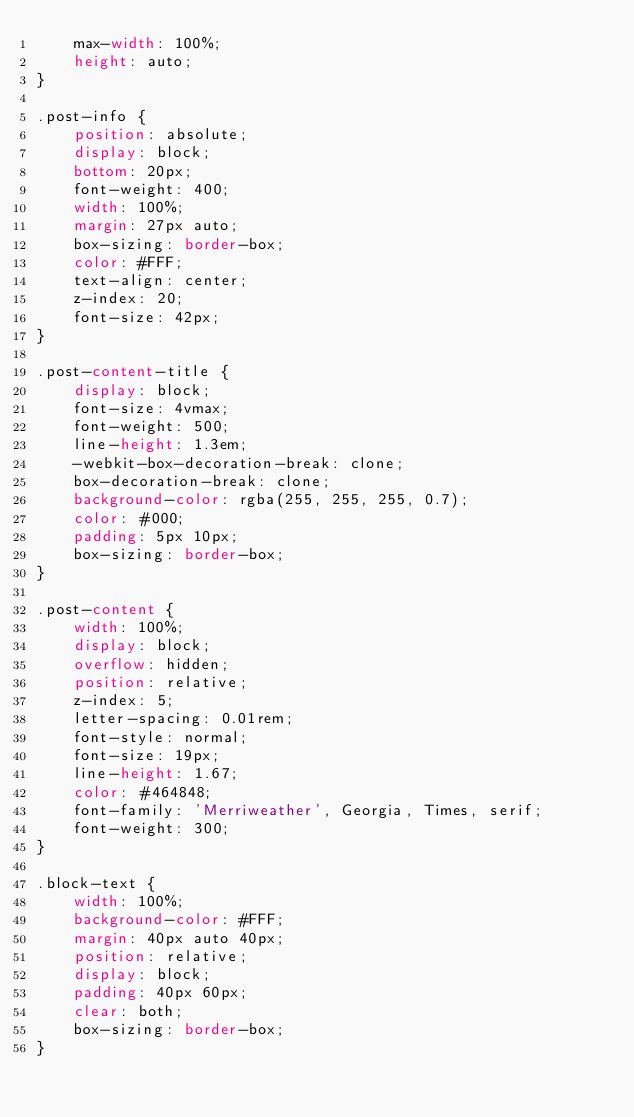<code> <loc_0><loc_0><loc_500><loc_500><_CSS_>    max-width: 100%;
    height: auto;
}

.post-info {
    position: absolute;
    display: block;
    bottom: 20px;
    font-weight: 400;
    width: 100%;
    margin: 27px auto;
    box-sizing: border-box;
    color: #FFF;
    text-align: center;
    z-index: 20;
    font-size: 42px;
}

.post-content-title {
    display: block;
    font-size: 4vmax;
    font-weight: 500;
    line-height: 1.3em;
    -webkit-box-decoration-break: clone;
    box-decoration-break: clone;
    background-color: rgba(255, 255, 255, 0.7);
    color: #000;
    padding: 5px 10px;
    box-sizing: border-box;
}

.post-content {
    width: 100%;
    display: block;
    overflow: hidden;
    position: relative;
    z-index: 5;
    letter-spacing: 0.01rem;
    font-style: normal;
    font-size: 19px;
    line-height: 1.67;
    color: #464848;
    font-family: 'Merriweather', Georgia, Times, serif;
    font-weight: 300;
}

.block-text {
    width: 100%;
    background-color: #FFF;
    margin: 40px auto 40px;
    position: relative;
    display: block;
    padding: 40px 60px;
    clear: both;
    box-sizing: border-box;
}

</code> 